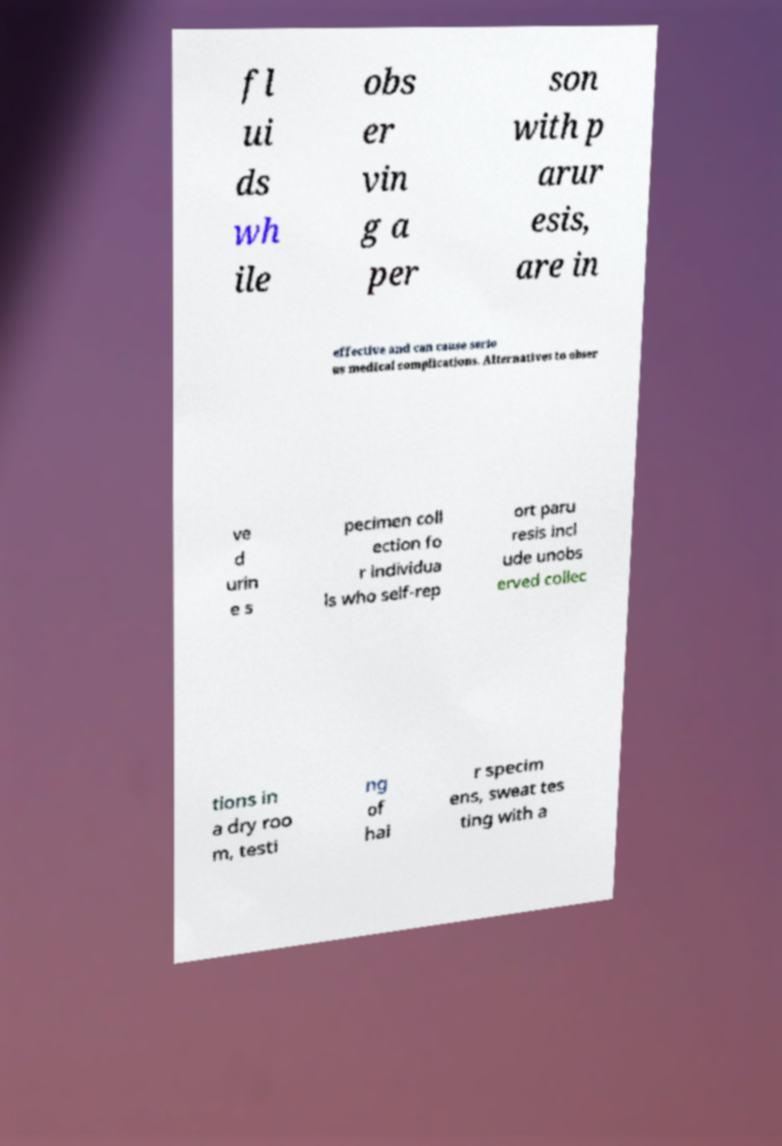Could you assist in decoding the text presented in this image and type it out clearly? fl ui ds wh ile obs er vin g a per son with p arur esis, are in effective and can cause serio us medical complications. Alternatives to obser ve d urin e s pecimen coll ection fo r individua ls who self-rep ort paru resis incl ude unobs erved collec tions in a dry roo m, testi ng of hai r specim ens, sweat tes ting with a 